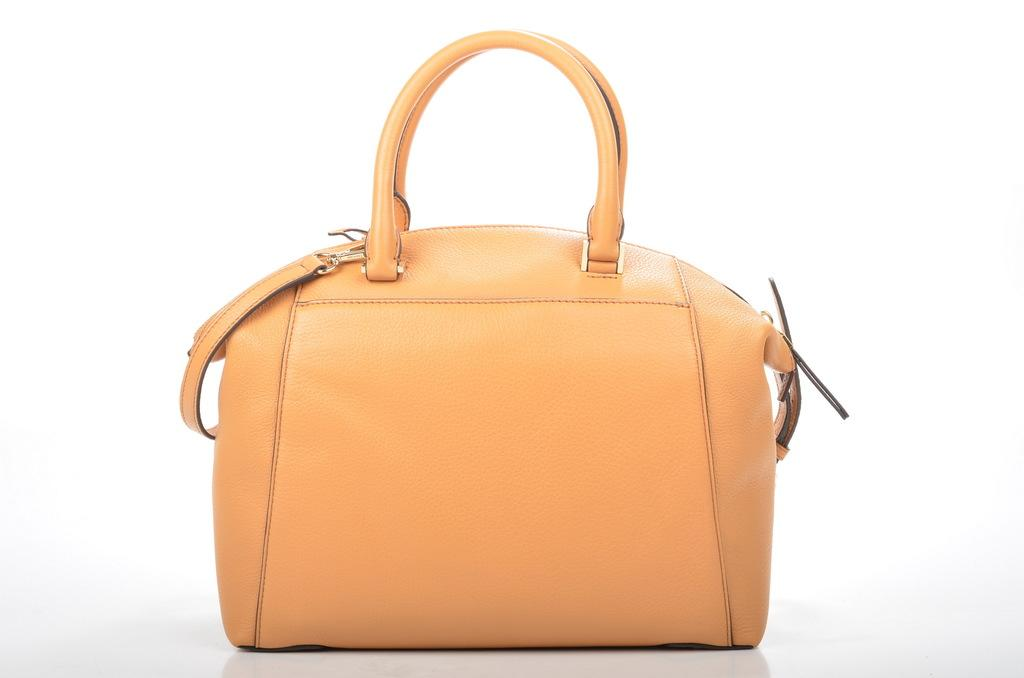What object can be seen in the image? There is a bag in the image. What type of waves can be seen crashing on the shore in the image? There are no waves or shore present in the image; it only features a bag. Is there a chair visible in the image? No, there is no chair present in the image; it only features a bag. 